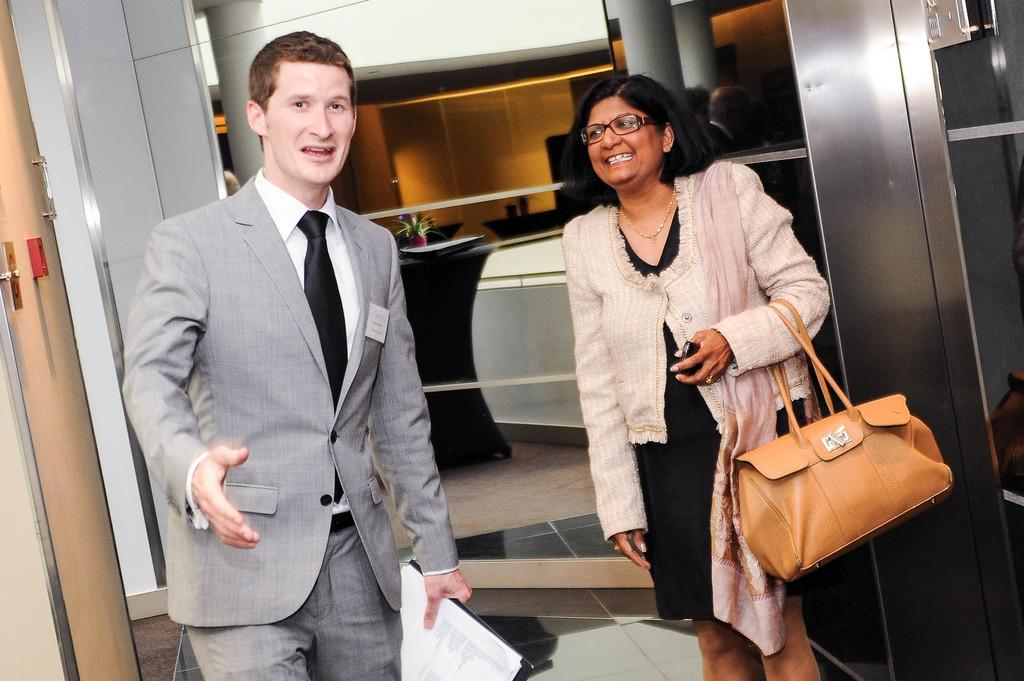How many people are present in the image? There are two people in the image. Can you describe the individuals in the image? One of the people is a lady, and the other person is a guy. What is the main piece of furniture in the image? There is a desk in the image. Are there any decorative or functional items on the desk? Yes, there is a plant on the desk. What type of bean can be seen growing on the plant in the image? There is no bean plant or bean visible in the image; it features a plant that is not specified. 